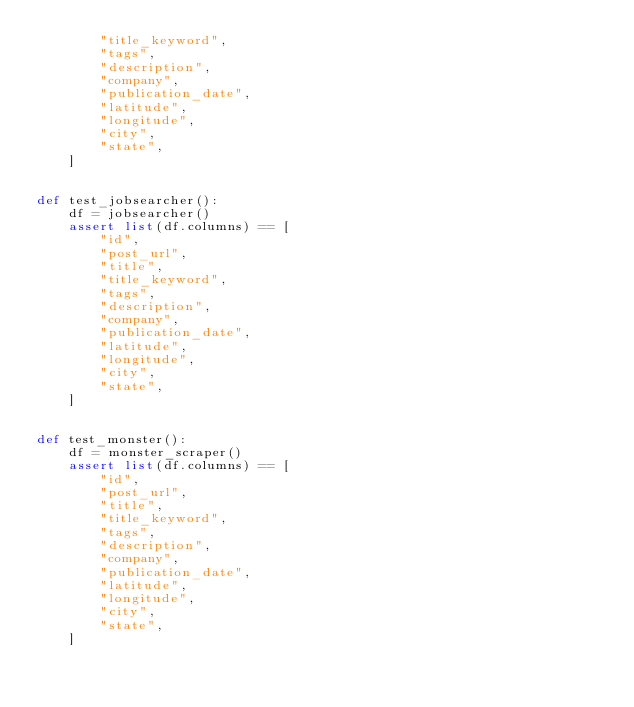Convert code to text. <code><loc_0><loc_0><loc_500><loc_500><_Python_>        "title_keyword",
        "tags",
        "description",
        "company",
        "publication_date",
        "latitude",
        "longitude",
        "city",
        "state",
    ]


def test_jobsearcher():
    df = jobsearcher()
    assert list(df.columns) == [
        "id",
        "post_url",
        "title",
        "title_keyword",
        "tags",
        "description",
        "company",
        "publication_date",
        "latitude",
        "longitude",
        "city",
        "state",
    ]


def test_monster():
    df = monster_scraper()
    assert list(df.columns) == [
        "id",
        "post_url",
        "title",
        "title_keyword",
        "tags",
        "description",
        "company",
        "publication_date",
        "latitude",
        "longitude",
        "city",
        "state",
    ]
</code> 